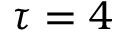Convert formula to latex. <formula><loc_0><loc_0><loc_500><loc_500>\tau = 4</formula> 